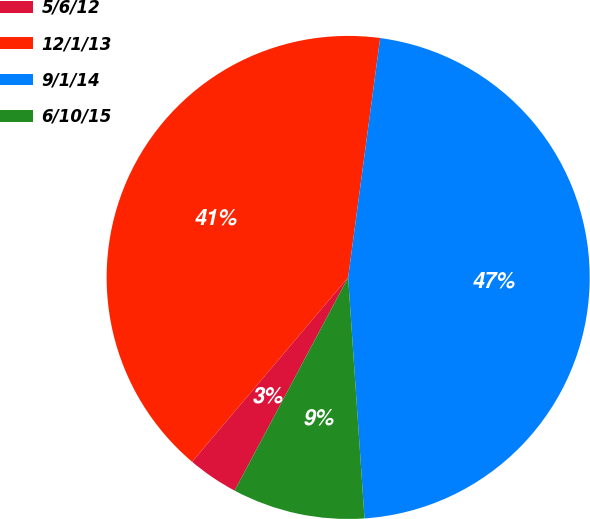<chart> <loc_0><loc_0><loc_500><loc_500><pie_chart><fcel>5/6/12<fcel>12/1/13<fcel>9/1/14<fcel>6/10/15<nl><fcel>3.39%<fcel>40.94%<fcel>46.81%<fcel>8.87%<nl></chart> 